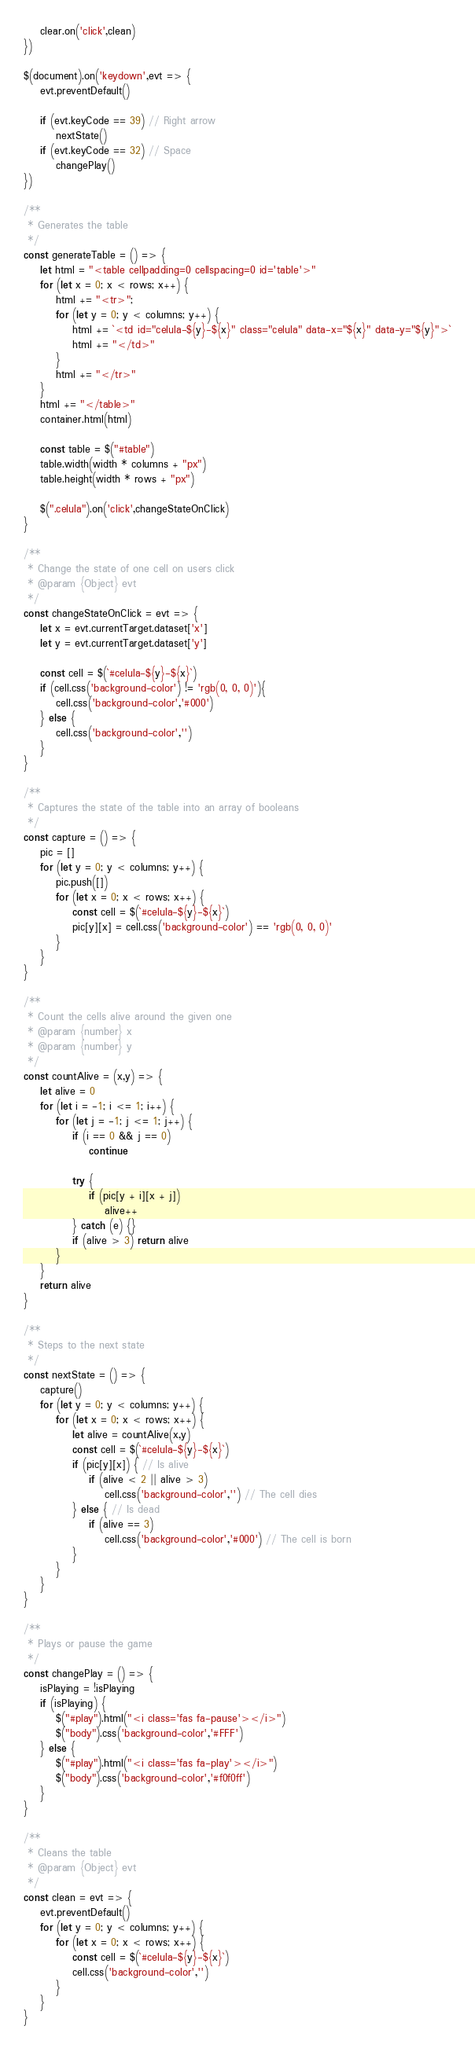<code> <loc_0><loc_0><loc_500><loc_500><_JavaScript_>    clear.on('click',clean)
})

$(document).on('keydown',evt => {
    evt.preventDefault()

    if (evt.keyCode == 39) // Right arrow
        nextState()
    if (evt.keyCode == 32) // Space
        changePlay()
})

/**
 * Generates the table
 */
const generateTable = () => {
    let html = "<table cellpadding=0 cellspacing=0 id='table'>"
    for (let x = 0; x < rows; x++) {
        html += "<tr>";
        for (let y = 0; y < columns; y++) {
            html += `<td id="celula-${y}-${x}" class="celula" data-x="${x}" data-y="${y}">`
            html += "</td>"
        }
        html += "</tr>"
    }
    html += "</table>"
    container.html(html)

    const table = $("#table")
    table.width(width * columns + "px")
    table.height(width * rows + "px")

    $(".celula").on('click',changeStateOnClick)
}

/**
 * Change the state of one cell on users click
 * @param {Object} evt 
 */
const changeStateOnClick = evt => {
    let x = evt.currentTarget.dataset['x']
    let y = evt.currentTarget.dataset['y']

    const cell = $(`#celula-${y}-${x}`)
    if (cell.css('background-color') != 'rgb(0, 0, 0)'){
        cell.css('background-color','#000')
    } else {
        cell.css('background-color','')
    }
}

/**
 * Captures the state of the table into an array of booleans
 */
const capture = () => {
    pic = []
    for (let y = 0; y < columns; y++) {
        pic.push([])
        for (let x = 0; x < rows; x++) {
            const cell = $(`#celula-${y}-${x}`)
            pic[y][x] = cell.css('background-color') == 'rgb(0, 0, 0)'
        }
    }
}

/**
 * Count the cells alive around the given one
 * @param {number} x 
 * @param {number} y 
 */
const countAlive = (x,y) => {
    let alive = 0
    for (let i = -1; i <= 1; i++) {
        for (let j = -1; j <= 1; j++) {
            if (i == 0 && j == 0)
                continue
            
            try {
                if (pic[y + i][x + j])
                    alive++
            } catch (e) {}
            if (alive > 3) return alive
        }
    }
    return alive
}

/**
 * Steps to the next state
 */
const nextState = () => {
    capture()
    for (let y = 0; y < columns; y++) {
        for (let x = 0; x < rows; x++) {
            let alive = countAlive(x,y)
            const cell = $(`#celula-${y}-${x}`)
            if (pic[y][x]) { // Is alive
                if (alive < 2 || alive > 3) 
                    cell.css('background-color','') // The cell dies
            } else { // Is dead
                if (alive == 3) 
                    cell.css('background-color','#000') // The cell is born
            }
        }
    }
}

/**
 * Plays or pause the game
 */
const changePlay = () => {
    isPlaying = !isPlaying
    if (isPlaying) {
        $("#play").html("<i class='fas fa-pause'></i>")
        $("body").css('background-color','#FFF')
    } else {
        $("#play").html("<i class='fas fa-play'></i>")
        $("body").css('background-color','#f0f0ff')
    }
}

/**
 * Cleans the table
 * @param {Object} evt 
 */
const clean = evt => {
    evt.preventDefault()
    for (let y = 0; y < columns; y++) {
        for (let x = 0; x < rows; x++) {
            const cell = $(`#celula-${y}-${x}`)
            cell.css('background-color','')
        }
    }
}
</code> 